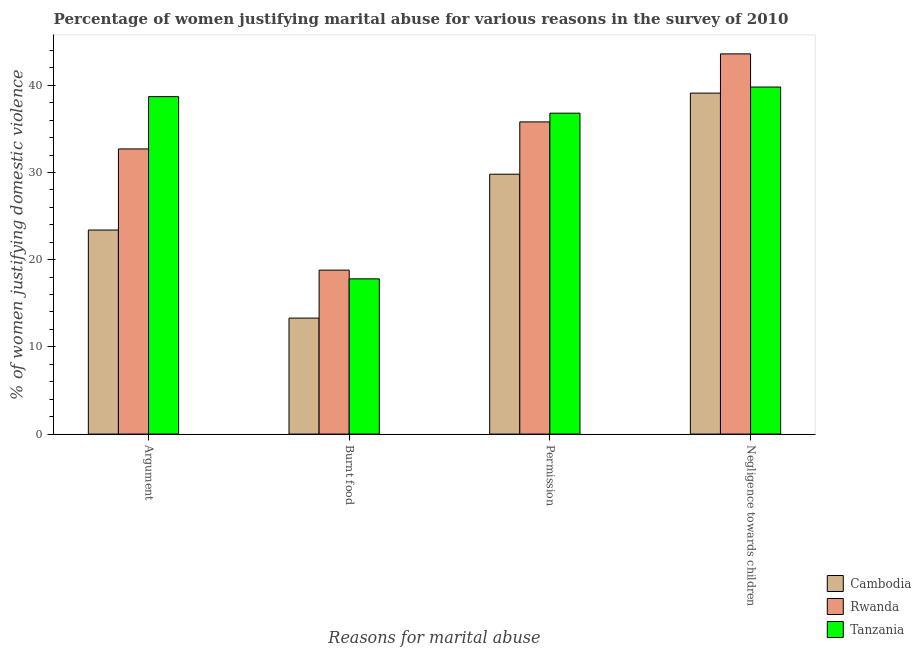Are the number of bars per tick equal to the number of legend labels?
Provide a short and direct response. Yes. Are the number of bars on each tick of the X-axis equal?
Keep it short and to the point. Yes. How many bars are there on the 2nd tick from the left?
Your answer should be compact. 3. What is the label of the 4th group of bars from the left?
Ensure brevity in your answer.  Negligence towards children. What is the percentage of women justifying abuse in the case of an argument in Rwanda?
Ensure brevity in your answer.  32.7. Across all countries, what is the maximum percentage of women justifying abuse for showing negligence towards children?
Your answer should be compact. 43.6. Across all countries, what is the minimum percentage of women justifying abuse for showing negligence towards children?
Your answer should be very brief. 39.1. In which country was the percentage of women justifying abuse for going without permission maximum?
Offer a very short reply. Tanzania. In which country was the percentage of women justifying abuse for going without permission minimum?
Ensure brevity in your answer.  Cambodia. What is the total percentage of women justifying abuse in the case of an argument in the graph?
Provide a short and direct response. 94.8. What is the difference between the percentage of women justifying abuse for going without permission in Rwanda and the percentage of women justifying abuse for showing negligence towards children in Cambodia?
Keep it short and to the point. -3.3. What is the average percentage of women justifying abuse in the case of an argument per country?
Provide a short and direct response. 31.6. What is the difference between the percentage of women justifying abuse in the case of an argument and percentage of women justifying abuse for going without permission in Cambodia?
Your answer should be compact. -6.4. In how many countries, is the percentage of women justifying abuse for showing negligence towards children greater than 26 %?
Ensure brevity in your answer.  3. What is the ratio of the percentage of women justifying abuse for burning food in Cambodia to that in Rwanda?
Make the answer very short. 0.71. Is the difference between the percentage of women justifying abuse in the case of an argument in Rwanda and Tanzania greater than the difference between the percentage of women justifying abuse for showing negligence towards children in Rwanda and Tanzania?
Your response must be concise. No. What is the difference between the highest and the lowest percentage of women justifying abuse for showing negligence towards children?
Provide a succinct answer. 4.5. What does the 2nd bar from the left in Negligence towards children represents?
Provide a succinct answer. Rwanda. What does the 3rd bar from the right in Negligence towards children represents?
Provide a short and direct response. Cambodia. Is it the case that in every country, the sum of the percentage of women justifying abuse in the case of an argument and percentage of women justifying abuse for burning food is greater than the percentage of women justifying abuse for going without permission?
Offer a very short reply. Yes. How many bars are there?
Make the answer very short. 12. Are all the bars in the graph horizontal?
Your answer should be very brief. No. What is the difference between two consecutive major ticks on the Y-axis?
Give a very brief answer. 10. Are the values on the major ticks of Y-axis written in scientific E-notation?
Make the answer very short. No. Does the graph contain any zero values?
Provide a succinct answer. No. Does the graph contain grids?
Make the answer very short. No. What is the title of the graph?
Keep it short and to the point. Percentage of women justifying marital abuse for various reasons in the survey of 2010. Does "Congo (Republic)" appear as one of the legend labels in the graph?
Ensure brevity in your answer.  No. What is the label or title of the X-axis?
Keep it short and to the point. Reasons for marital abuse. What is the label or title of the Y-axis?
Provide a short and direct response. % of women justifying domestic violence. What is the % of women justifying domestic violence of Cambodia in Argument?
Offer a very short reply. 23.4. What is the % of women justifying domestic violence in Rwanda in Argument?
Your answer should be compact. 32.7. What is the % of women justifying domestic violence of Tanzania in Argument?
Offer a terse response. 38.7. What is the % of women justifying domestic violence in Cambodia in Permission?
Your answer should be very brief. 29.8. What is the % of women justifying domestic violence of Rwanda in Permission?
Your answer should be very brief. 35.8. What is the % of women justifying domestic violence in Tanzania in Permission?
Your answer should be compact. 36.8. What is the % of women justifying domestic violence in Cambodia in Negligence towards children?
Keep it short and to the point. 39.1. What is the % of women justifying domestic violence of Rwanda in Negligence towards children?
Offer a very short reply. 43.6. What is the % of women justifying domestic violence in Tanzania in Negligence towards children?
Keep it short and to the point. 39.8. Across all Reasons for marital abuse, what is the maximum % of women justifying domestic violence in Cambodia?
Ensure brevity in your answer.  39.1. Across all Reasons for marital abuse, what is the maximum % of women justifying domestic violence in Rwanda?
Your answer should be compact. 43.6. Across all Reasons for marital abuse, what is the maximum % of women justifying domestic violence in Tanzania?
Provide a short and direct response. 39.8. Across all Reasons for marital abuse, what is the minimum % of women justifying domestic violence of Rwanda?
Provide a short and direct response. 18.8. Across all Reasons for marital abuse, what is the minimum % of women justifying domestic violence of Tanzania?
Give a very brief answer. 17.8. What is the total % of women justifying domestic violence in Cambodia in the graph?
Your response must be concise. 105.6. What is the total % of women justifying domestic violence of Rwanda in the graph?
Provide a succinct answer. 130.9. What is the total % of women justifying domestic violence of Tanzania in the graph?
Keep it short and to the point. 133.1. What is the difference between the % of women justifying domestic violence of Cambodia in Argument and that in Burnt food?
Offer a very short reply. 10.1. What is the difference between the % of women justifying domestic violence of Rwanda in Argument and that in Burnt food?
Offer a very short reply. 13.9. What is the difference between the % of women justifying domestic violence of Tanzania in Argument and that in Burnt food?
Offer a very short reply. 20.9. What is the difference between the % of women justifying domestic violence of Cambodia in Argument and that in Permission?
Ensure brevity in your answer.  -6.4. What is the difference between the % of women justifying domestic violence in Cambodia in Argument and that in Negligence towards children?
Keep it short and to the point. -15.7. What is the difference between the % of women justifying domestic violence of Rwanda in Argument and that in Negligence towards children?
Provide a short and direct response. -10.9. What is the difference between the % of women justifying domestic violence of Tanzania in Argument and that in Negligence towards children?
Make the answer very short. -1.1. What is the difference between the % of women justifying domestic violence in Cambodia in Burnt food and that in Permission?
Offer a terse response. -16.5. What is the difference between the % of women justifying domestic violence of Rwanda in Burnt food and that in Permission?
Provide a succinct answer. -17. What is the difference between the % of women justifying domestic violence of Tanzania in Burnt food and that in Permission?
Provide a succinct answer. -19. What is the difference between the % of women justifying domestic violence in Cambodia in Burnt food and that in Negligence towards children?
Offer a terse response. -25.8. What is the difference between the % of women justifying domestic violence in Rwanda in Burnt food and that in Negligence towards children?
Your answer should be very brief. -24.8. What is the difference between the % of women justifying domestic violence of Cambodia in Permission and that in Negligence towards children?
Ensure brevity in your answer.  -9.3. What is the difference between the % of women justifying domestic violence in Rwanda in Permission and that in Negligence towards children?
Give a very brief answer. -7.8. What is the difference between the % of women justifying domestic violence of Cambodia in Argument and the % of women justifying domestic violence of Rwanda in Burnt food?
Offer a very short reply. 4.6. What is the difference between the % of women justifying domestic violence in Rwanda in Argument and the % of women justifying domestic violence in Tanzania in Burnt food?
Give a very brief answer. 14.9. What is the difference between the % of women justifying domestic violence in Cambodia in Argument and the % of women justifying domestic violence in Rwanda in Permission?
Your answer should be very brief. -12.4. What is the difference between the % of women justifying domestic violence of Cambodia in Argument and the % of women justifying domestic violence of Tanzania in Permission?
Provide a short and direct response. -13.4. What is the difference between the % of women justifying domestic violence of Rwanda in Argument and the % of women justifying domestic violence of Tanzania in Permission?
Provide a short and direct response. -4.1. What is the difference between the % of women justifying domestic violence in Cambodia in Argument and the % of women justifying domestic violence in Rwanda in Negligence towards children?
Your answer should be compact. -20.2. What is the difference between the % of women justifying domestic violence in Cambodia in Argument and the % of women justifying domestic violence in Tanzania in Negligence towards children?
Your response must be concise. -16.4. What is the difference between the % of women justifying domestic violence in Cambodia in Burnt food and the % of women justifying domestic violence in Rwanda in Permission?
Make the answer very short. -22.5. What is the difference between the % of women justifying domestic violence of Cambodia in Burnt food and the % of women justifying domestic violence of Tanzania in Permission?
Your answer should be very brief. -23.5. What is the difference between the % of women justifying domestic violence of Cambodia in Burnt food and the % of women justifying domestic violence of Rwanda in Negligence towards children?
Provide a short and direct response. -30.3. What is the difference between the % of women justifying domestic violence of Cambodia in Burnt food and the % of women justifying domestic violence of Tanzania in Negligence towards children?
Offer a terse response. -26.5. What is the difference between the % of women justifying domestic violence of Cambodia in Permission and the % of women justifying domestic violence of Tanzania in Negligence towards children?
Your response must be concise. -10. What is the difference between the % of women justifying domestic violence of Rwanda in Permission and the % of women justifying domestic violence of Tanzania in Negligence towards children?
Your response must be concise. -4. What is the average % of women justifying domestic violence of Cambodia per Reasons for marital abuse?
Ensure brevity in your answer.  26.4. What is the average % of women justifying domestic violence in Rwanda per Reasons for marital abuse?
Your answer should be very brief. 32.73. What is the average % of women justifying domestic violence in Tanzania per Reasons for marital abuse?
Keep it short and to the point. 33.27. What is the difference between the % of women justifying domestic violence in Cambodia and % of women justifying domestic violence in Rwanda in Argument?
Give a very brief answer. -9.3. What is the difference between the % of women justifying domestic violence in Cambodia and % of women justifying domestic violence in Tanzania in Argument?
Keep it short and to the point. -15.3. What is the difference between the % of women justifying domestic violence of Rwanda and % of women justifying domestic violence of Tanzania in Argument?
Your answer should be very brief. -6. What is the difference between the % of women justifying domestic violence of Cambodia and % of women justifying domestic violence of Tanzania in Burnt food?
Make the answer very short. -4.5. What is the difference between the % of women justifying domestic violence in Rwanda and % of women justifying domestic violence in Tanzania in Burnt food?
Offer a very short reply. 1. What is the difference between the % of women justifying domestic violence of Cambodia and % of women justifying domestic violence of Rwanda in Permission?
Your answer should be compact. -6. What is the difference between the % of women justifying domestic violence in Cambodia and % of women justifying domestic violence in Tanzania in Permission?
Ensure brevity in your answer.  -7. What is the difference between the % of women justifying domestic violence in Cambodia and % of women justifying domestic violence in Tanzania in Negligence towards children?
Offer a very short reply. -0.7. What is the ratio of the % of women justifying domestic violence in Cambodia in Argument to that in Burnt food?
Make the answer very short. 1.76. What is the ratio of the % of women justifying domestic violence of Rwanda in Argument to that in Burnt food?
Offer a terse response. 1.74. What is the ratio of the % of women justifying domestic violence of Tanzania in Argument to that in Burnt food?
Your answer should be very brief. 2.17. What is the ratio of the % of women justifying domestic violence of Cambodia in Argument to that in Permission?
Offer a very short reply. 0.79. What is the ratio of the % of women justifying domestic violence of Rwanda in Argument to that in Permission?
Your answer should be very brief. 0.91. What is the ratio of the % of women justifying domestic violence of Tanzania in Argument to that in Permission?
Provide a short and direct response. 1.05. What is the ratio of the % of women justifying domestic violence in Cambodia in Argument to that in Negligence towards children?
Provide a succinct answer. 0.6. What is the ratio of the % of women justifying domestic violence in Rwanda in Argument to that in Negligence towards children?
Ensure brevity in your answer.  0.75. What is the ratio of the % of women justifying domestic violence of Tanzania in Argument to that in Negligence towards children?
Your response must be concise. 0.97. What is the ratio of the % of women justifying domestic violence in Cambodia in Burnt food to that in Permission?
Your response must be concise. 0.45. What is the ratio of the % of women justifying domestic violence in Rwanda in Burnt food to that in Permission?
Your answer should be very brief. 0.53. What is the ratio of the % of women justifying domestic violence in Tanzania in Burnt food to that in Permission?
Your response must be concise. 0.48. What is the ratio of the % of women justifying domestic violence of Cambodia in Burnt food to that in Negligence towards children?
Ensure brevity in your answer.  0.34. What is the ratio of the % of women justifying domestic violence of Rwanda in Burnt food to that in Negligence towards children?
Offer a terse response. 0.43. What is the ratio of the % of women justifying domestic violence in Tanzania in Burnt food to that in Negligence towards children?
Offer a very short reply. 0.45. What is the ratio of the % of women justifying domestic violence in Cambodia in Permission to that in Negligence towards children?
Offer a terse response. 0.76. What is the ratio of the % of women justifying domestic violence in Rwanda in Permission to that in Negligence towards children?
Provide a succinct answer. 0.82. What is the ratio of the % of women justifying domestic violence of Tanzania in Permission to that in Negligence towards children?
Your response must be concise. 0.92. What is the difference between the highest and the second highest % of women justifying domestic violence in Cambodia?
Keep it short and to the point. 9.3. What is the difference between the highest and the lowest % of women justifying domestic violence in Cambodia?
Offer a very short reply. 25.8. What is the difference between the highest and the lowest % of women justifying domestic violence in Rwanda?
Provide a short and direct response. 24.8. 